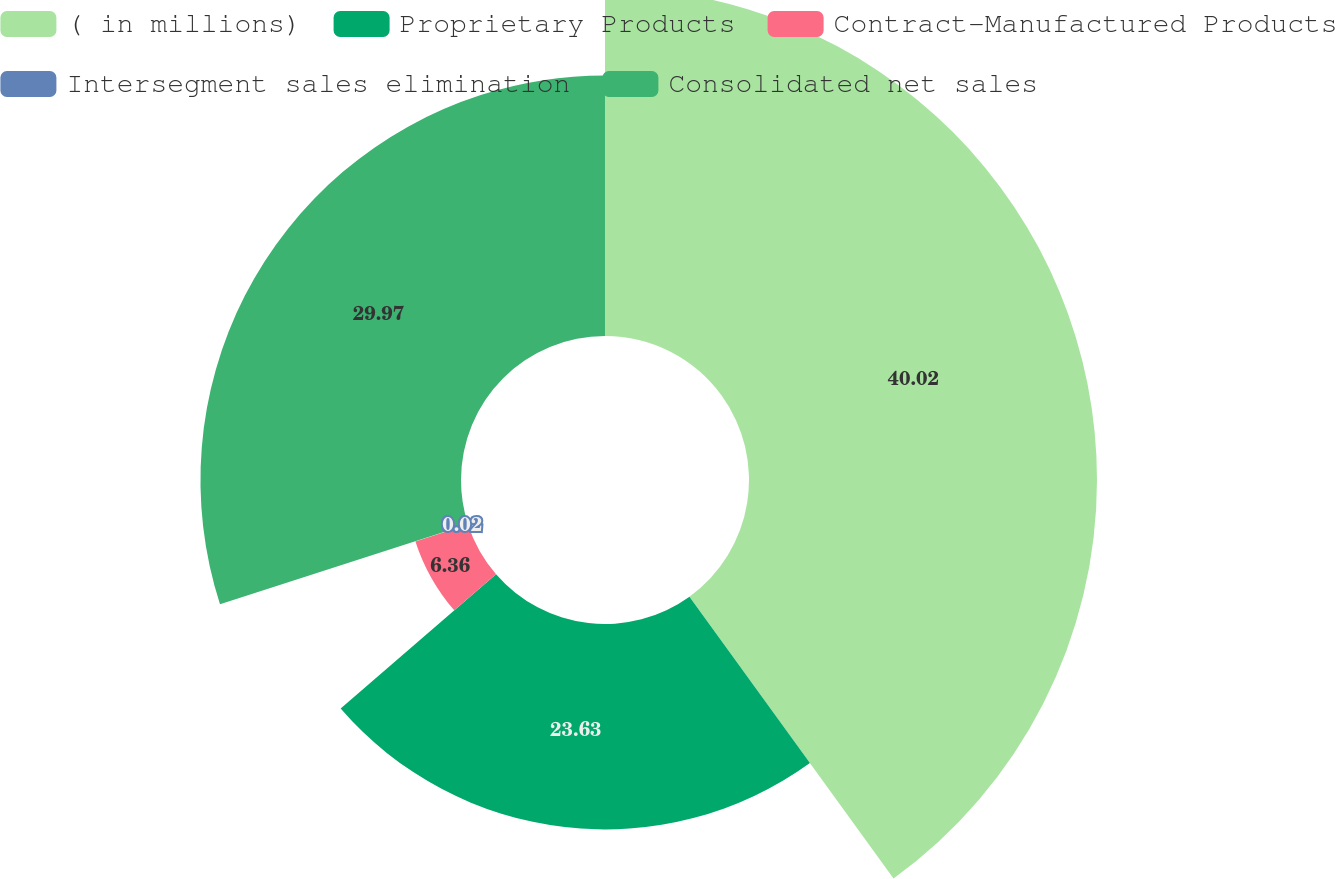<chart> <loc_0><loc_0><loc_500><loc_500><pie_chart><fcel>( in millions)<fcel>Proprietary Products<fcel>Contract-Manufactured Products<fcel>Intersegment sales elimination<fcel>Consolidated net sales<nl><fcel>40.03%<fcel>23.63%<fcel>6.36%<fcel>0.02%<fcel>29.97%<nl></chart> 